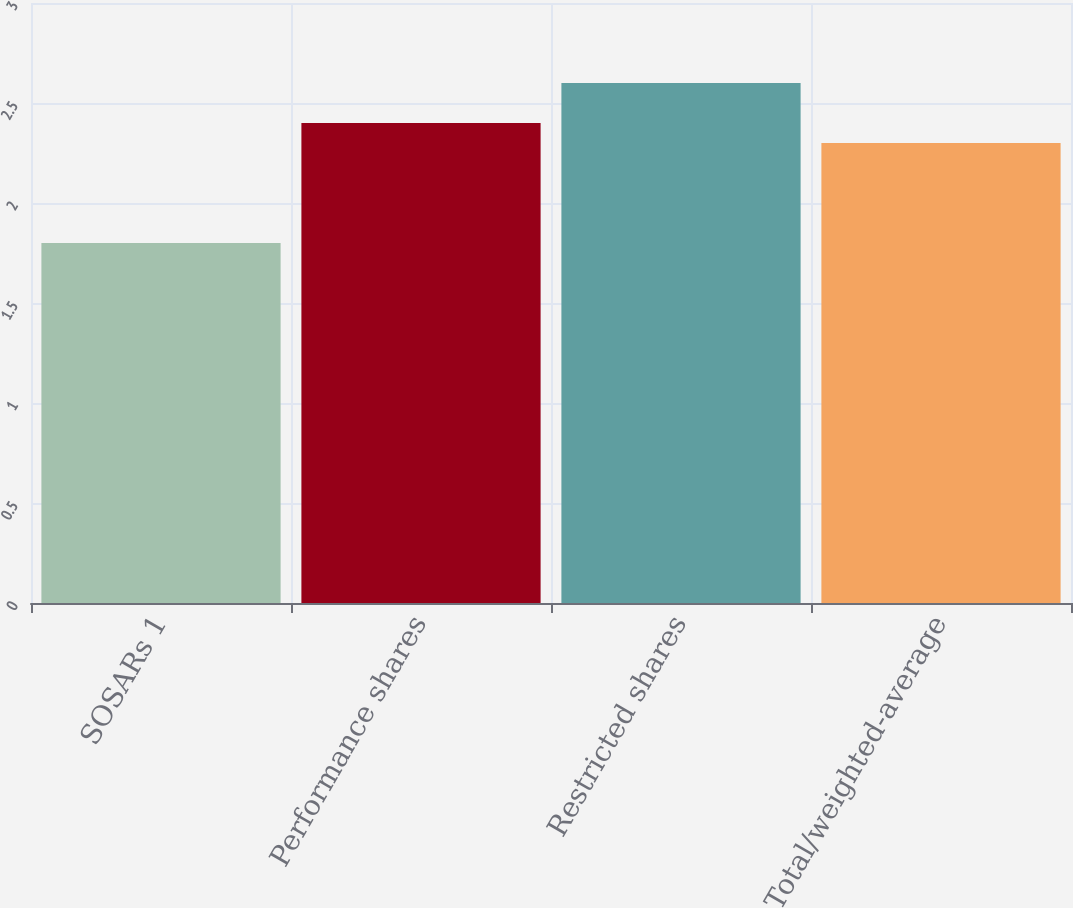<chart> <loc_0><loc_0><loc_500><loc_500><bar_chart><fcel>SOSARs 1<fcel>Performance shares<fcel>Restricted shares<fcel>Total/weighted-average<nl><fcel>1.8<fcel>2.4<fcel>2.6<fcel>2.3<nl></chart> 